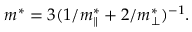<formula> <loc_0><loc_0><loc_500><loc_500>m ^ { * } = 3 ( 1 / m _ { \| } ^ { * } + 2 / m _ { \perp } ^ { * } ) ^ { - 1 } .</formula> 